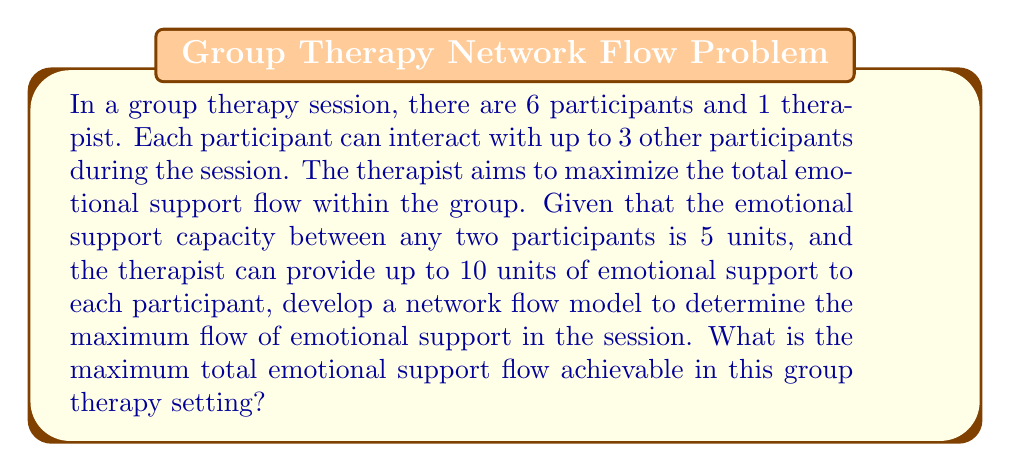Help me with this question. To solve this problem, we'll use a network flow model. Let's break it down step-by-step:

1. Define the network:
   - Source node (s): represents the therapist
   - Sink node (t): represents the overall emotional support received
   - Nodes 1-6: represent the 6 participants

2. Define the edges and capacities:
   - Edges from s to each participant: capacity 10 units
   - Edges between participants: capacity 5 units
   - Edges from each participant to t: unlimited capacity

3. Set up the mathematical model:
   Let $x_{ij}$ represent the flow from node i to node j.

   Objective function: Maximize $\sum_{i=1}^6 x_{it}$

   Subject to:
   - Flow conservation: $\sum_{j} x_{ij} - \sum_{j} x_{ji} = 0$ for all nodes except s and t
   - Capacity constraints:
     $x_{si} \leq 10$ for $i = 1,\ldots,6$
     $x_{ij} \leq 5$ for all participant pairs $(i,j)$
     $\sum_{j \neq i} x_{ij} \leq 3 \cdot 5 = 15$ for each participant i

4. Solve the maximum flow problem:
   We can use algorithms like Ford-Fulkerson or Edmonds-Karp to solve this problem. However, we can also reason about the maximum flow:

   - Each participant can receive up to 10 units from the therapist and up to 15 units from other participants (3 connections * 5 units each).
   - The total inflow for each participant is limited to 25 units.
   - With 6 participants, the theoretical maximum flow is 6 * 25 = 150 units.
   - However, the therapist can only provide 6 * 10 = 60 units in total.

   Therefore, the maximum achievable flow is 60 units from the therapist plus 5 * 15 = 75 units from participant interactions, totaling 135 units.

5. Psychological interpretation:
   This model represents the flow of emotional support in the group therapy session, with the maximum flow indicating the optimal distribution of support among participants, considering both therapist-participant and participant-participant interactions.
Answer: The maximum total emotional support flow achievable in this group therapy setting is 135 units. 